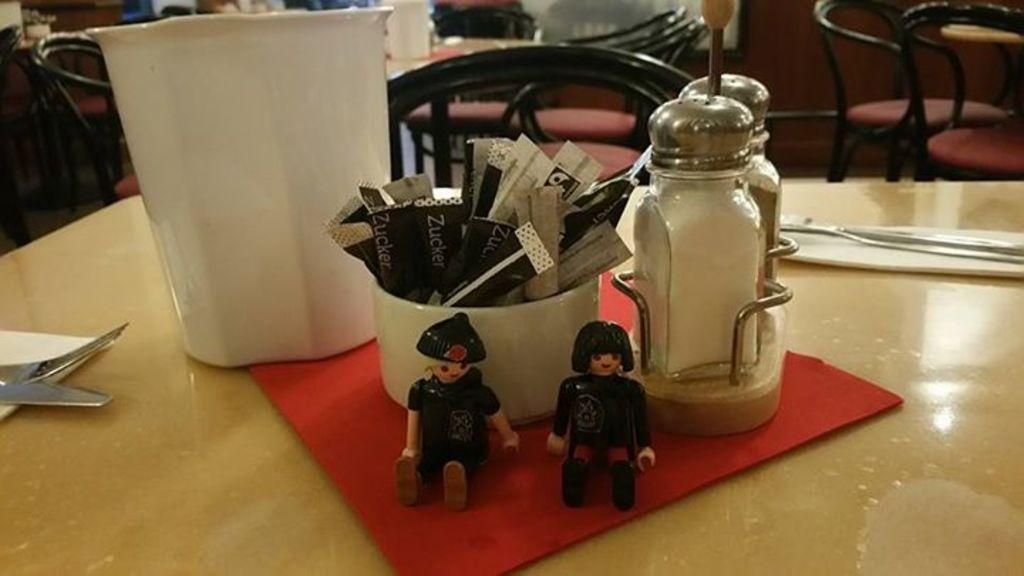What type of furniture is present in the image? There are chairs and a table in the image. What objects can be seen on the table? There are two dolls, a bowl, a jar, a knife, a fork, and a cloth on the table. How many dolls are on the table? There are two dolls on the table. What type of pain can be seen on the dolls' faces in the image? There is no indication of pain on the dolls' faces in the image, as they are inanimate objects. 